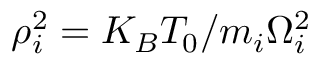<formula> <loc_0><loc_0><loc_500><loc_500>\rho _ { i } ^ { 2 } = K _ { B } T _ { 0 } / m _ { i } \Omega _ { i } ^ { 2 }</formula> 